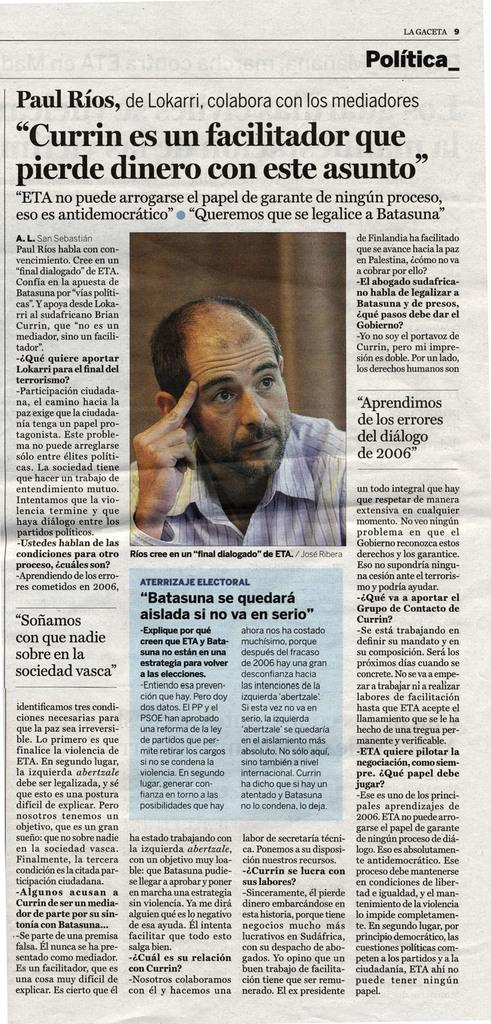What is depicted on the paper in the image? There is a person's image on the paper. What else can be seen on the paper besides the image? There is text on the paper in the image. How many stars can be seen in the image? There are no stars present in the image. What type of mist surrounds the person's image on the paper? There is no mist present in the image; it only shows a paper with text and a person's image. 